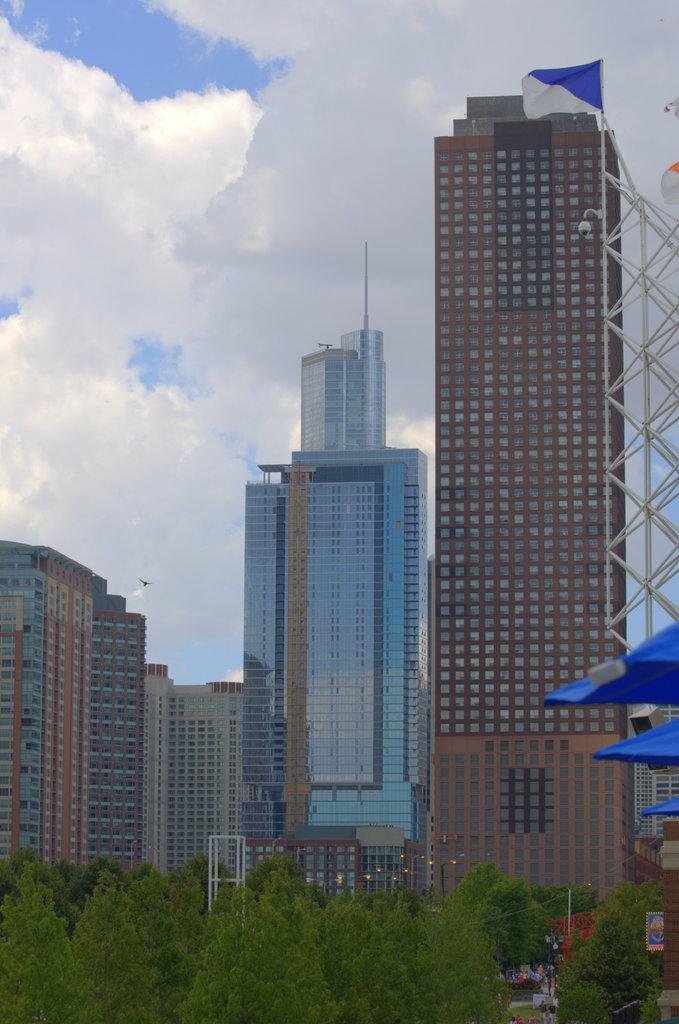What type of structures are visible in the image? There are tall buildings in the image. What can be seen in front of the buildings? There are trees in front of the buildings. What is visible in the background of the image? The sky is visible in the background of the image. What can be observed in the sky? Clouds are present in the sky. What type of stew is being cooked by the grandmother in the image? There is no grandmother or stew present in the image. 